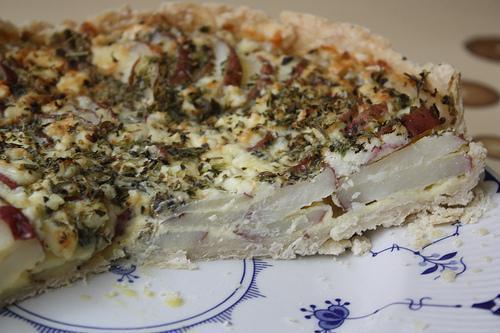How many quiches are in the photo?
Give a very brief answer. 1. How many people are in the photo?
Give a very brief answer. 0. 